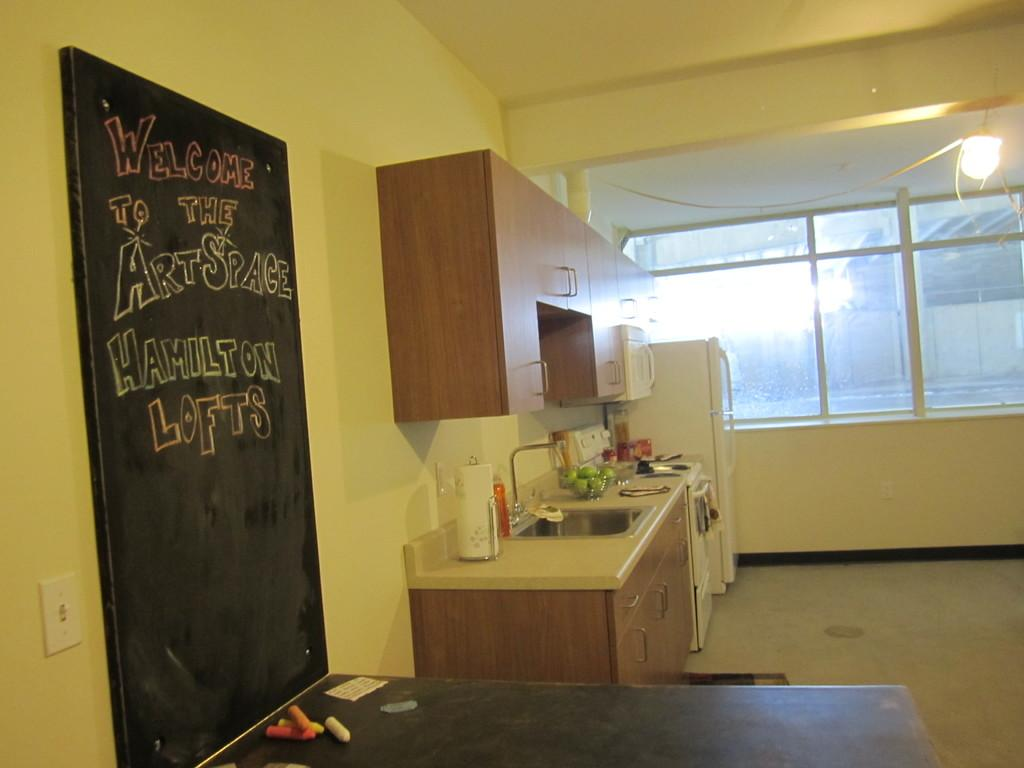Provide a one-sentence caption for the provided image. a shared kitchen with black board that reads Welcome to the Art Space. 